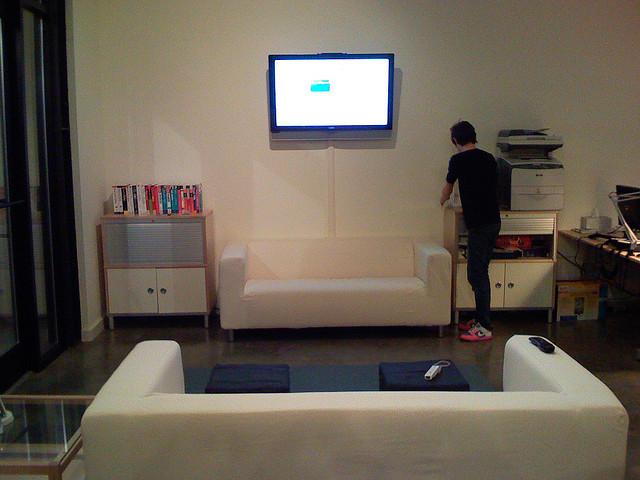Are these designer couches?
Be succinct. Yes. What is the bright object on the wall?
Concise answer only. Tv. How many couches are there?
Be succinct. 2. 